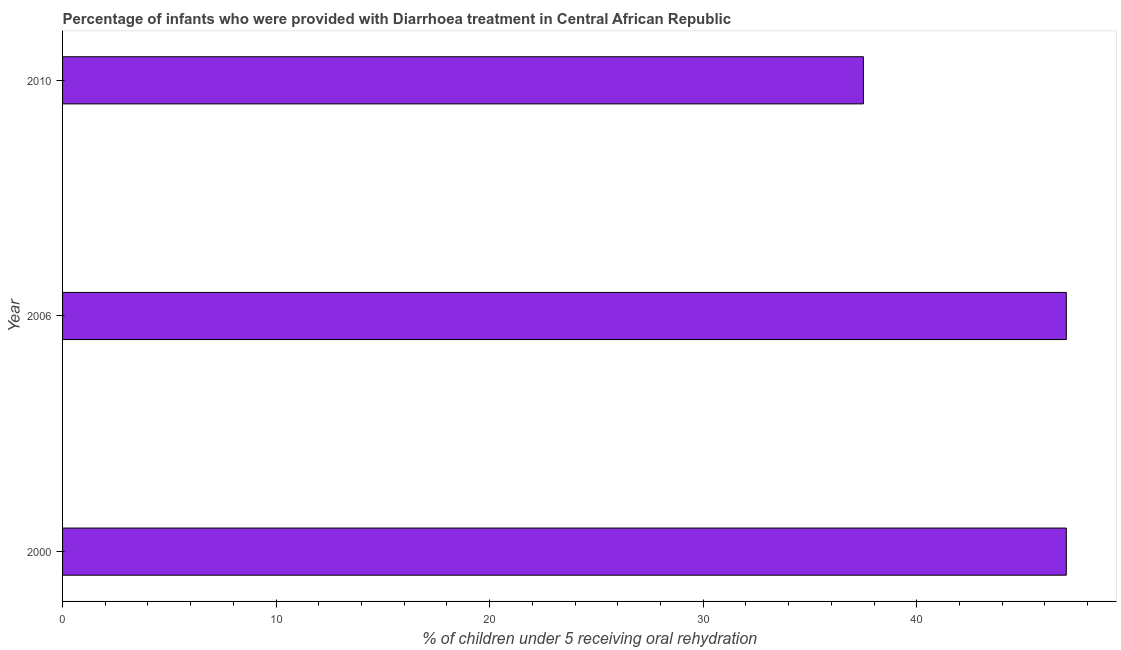What is the title of the graph?
Keep it short and to the point. Percentage of infants who were provided with Diarrhoea treatment in Central African Republic. What is the label or title of the X-axis?
Your response must be concise. % of children under 5 receiving oral rehydration. What is the percentage of children who were provided with treatment diarrhoea in 2006?
Your answer should be very brief. 47. Across all years, what is the minimum percentage of children who were provided with treatment diarrhoea?
Your answer should be compact. 37.5. In which year was the percentage of children who were provided with treatment diarrhoea minimum?
Ensure brevity in your answer.  2010. What is the sum of the percentage of children who were provided with treatment diarrhoea?
Your answer should be compact. 131.5. What is the difference between the percentage of children who were provided with treatment diarrhoea in 2000 and 2010?
Provide a short and direct response. 9.5. What is the average percentage of children who were provided with treatment diarrhoea per year?
Ensure brevity in your answer.  43.83. Do a majority of the years between 2006 and 2010 (inclusive) have percentage of children who were provided with treatment diarrhoea greater than 8 %?
Give a very brief answer. Yes. What is the ratio of the percentage of children who were provided with treatment diarrhoea in 2000 to that in 2006?
Your response must be concise. 1. Is the percentage of children who were provided with treatment diarrhoea in 2000 less than that in 2006?
Offer a terse response. No. Is the sum of the percentage of children who were provided with treatment diarrhoea in 2000 and 2010 greater than the maximum percentage of children who were provided with treatment diarrhoea across all years?
Ensure brevity in your answer.  Yes. How many bars are there?
Offer a very short reply. 3. Are all the bars in the graph horizontal?
Keep it short and to the point. Yes. What is the difference between two consecutive major ticks on the X-axis?
Offer a very short reply. 10. Are the values on the major ticks of X-axis written in scientific E-notation?
Ensure brevity in your answer.  No. What is the % of children under 5 receiving oral rehydration of 2000?
Your response must be concise. 47. What is the % of children under 5 receiving oral rehydration of 2010?
Your answer should be very brief. 37.5. What is the difference between the % of children under 5 receiving oral rehydration in 2006 and 2010?
Offer a terse response. 9.5. What is the ratio of the % of children under 5 receiving oral rehydration in 2000 to that in 2006?
Your answer should be very brief. 1. What is the ratio of the % of children under 5 receiving oral rehydration in 2000 to that in 2010?
Give a very brief answer. 1.25. What is the ratio of the % of children under 5 receiving oral rehydration in 2006 to that in 2010?
Make the answer very short. 1.25. 